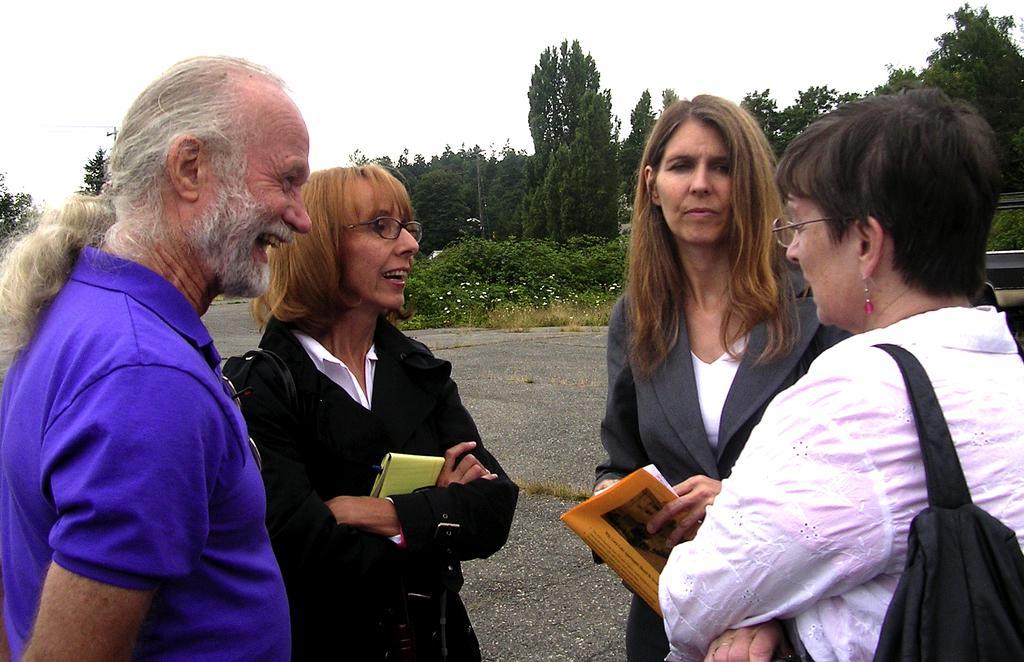Describe this image in one or two sentences. In this image we can see four people standing on the road, one vehicle on the road, two people with spectacles wearing black bags, some plants with flowers, two people holding objects, some trees, bushes, plants and grass on the ground. At the top there is the sky. 